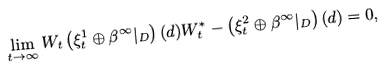Convert formula to latex. <formula><loc_0><loc_0><loc_500><loc_500>\lim _ { t \to \infty } W _ { t } \left ( \xi ^ { 1 } _ { t } \oplus \beta ^ { \infty } | _ { D } \right ) ( d ) W _ { t } ^ { * } - \left ( \xi ^ { 2 } _ { t } \oplus \beta ^ { \infty } | _ { D } \right ) ( d ) = 0 ,</formula> 